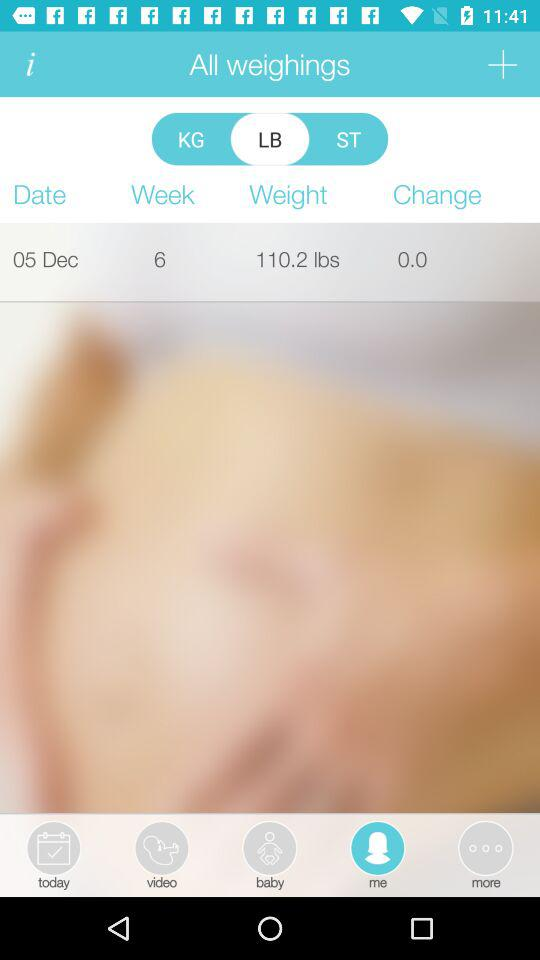Which tab has been selected? The selected tab is "me". 